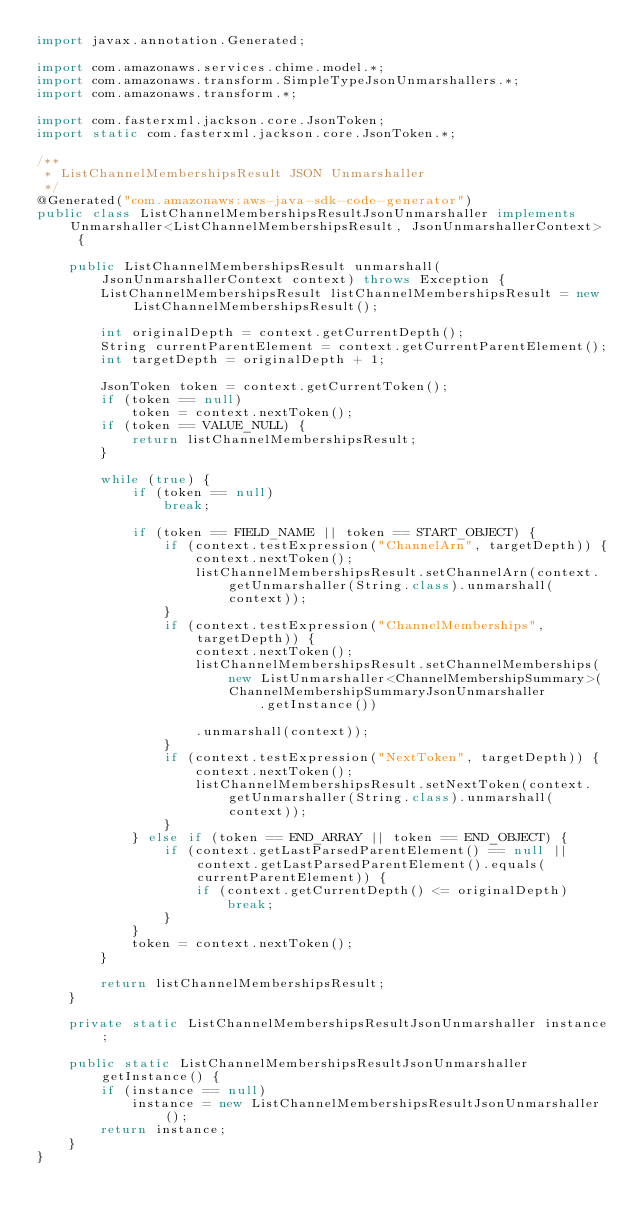<code> <loc_0><loc_0><loc_500><loc_500><_Java_>import javax.annotation.Generated;

import com.amazonaws.services.chime.model.*;
import com.amazonaws.transform.SimpleTypeJsonUnmarshallers.*;
import com.amazonaws.transform.*;

import com.fasterxml.jackson.core.JsonToken;
import static com.fasterxml.jackson.core.JsonToken.*;

/**
 * ListChannelMembershipsResult JSON Unmarshaller
 */
@Generated("com.amazonaws:aws-java-sdk-code-generator")
public class ListChannelMembershipsResultJsonUnmarshaller implements Unmarshaller<ListChannelMembershipsResult, JsonUnmarshallerContext> {

    public ListChannelMembershipsResult unmarshall(JsonUnmarshallerContext context) throws Exception {
        ListChannelMembershipsResult listChannelMembershipsResult = new ListChannelMembershipsResult();

        int originalDepth = context.getCurrentDepth();
        String currentParentElement = context.getCurrentParentElement();
        int targetDepth = originalDepth + 1;

        JsonToken token = context.getCurrentToken();
        if (token == null)
            token = context.nextToken();
        if (token == VALUE_NULL) {
            return listChannelMembershipsResult;
        }

        while (true) {
            if (token == null)
                break;

            if (token == FIELD_NAME || token == START_OBJECT) {
                if (context.testExpression("ChannelArn", targetDepth)) {
                    context.nextToken();
                    listChannelMembershipsResult.setChannelArn(context.getUnmarshaller(String.class).unmarshall(context));
                }
                if (context.testExpression("ChannelMemberships", targetDepth)) {
                    context.nextToken();
                    listChannelMembershipsResult.setChannelMemberships(new ListUnmarshaller<ChannelMembershipSummary>(ChannelMembershipSummaryJsonUnmarshaller
                            .getInstance())

                    .unmarshall(context));
                }
                if (context.testExpression("NextToken", targetDepth)) {
                    context.nextToken();
                    listChannelMembershipsResult.setNextToken(context.getUnmarshaller(String.class).unmarshall(context));
                }
            } else if (token == END_ARRAY || token == END_OBJECT) {
                if (context.getLastParsedParentElement() == null || context.getLastParsedParentElement().equals(currentParentElement)) {
                    if (context.getCurrentDepth() <= originalDepth)
                        break;
                }
            }
            token = context.nextToken();
        }

        return listChannelMembershipsResult;
    }

    private static ListChannelMembershipsResultJsonUnmarshaller instance;

    public static ListChannelMembershipsResultJsonUnmarshaller getInstance() {
        if (instance == null)
            instance = new ListChannelMembershipsResultJsonUnmarshaller();
        return instance;
    }
}
</code> 